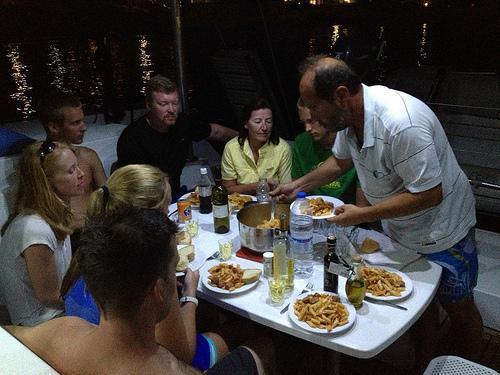How many plates are visible?
Give a very brief answer. 6. How many people are shirtless?
Give a very brief answer. 2. How many people are in this photo?
Give a very brief answer. 8. 